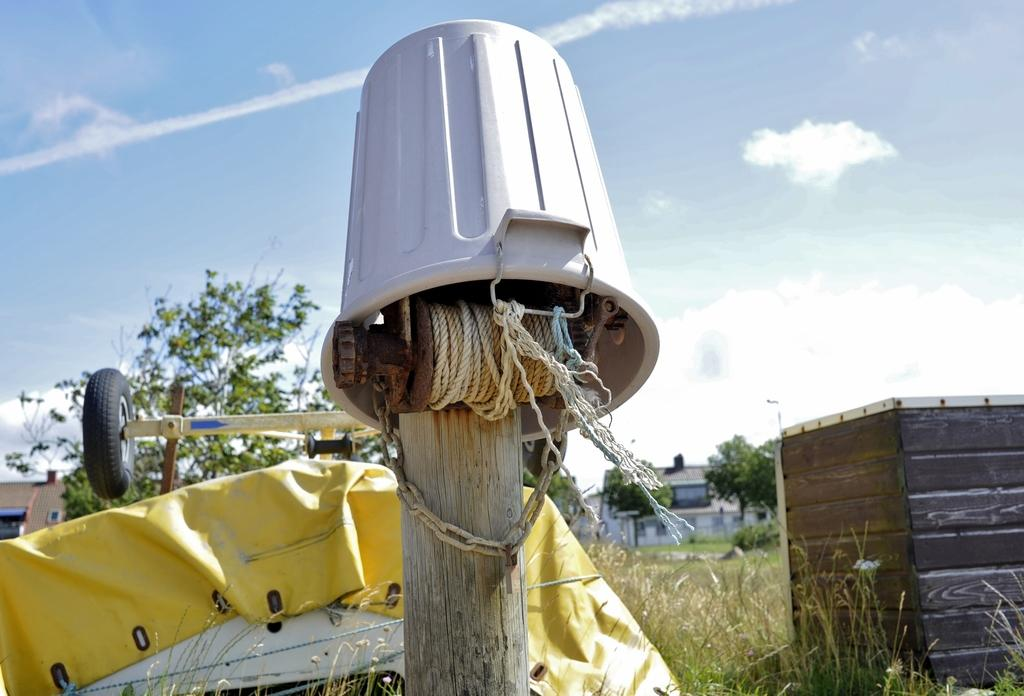What is the main object in the image? There is a wooden pole in the image. What is attached to the wooden pole? A machine is attached to the wooden pole. What is hanging from the wooden pole? There is a bucket on the wooden pole. How many objects can be seen in the image? There are two objects in the image, the wooden pole and the machine. What type of vegetation is visible in the image? There is grass visible in the image. What can be seen in the background of the image? There are houses, trees, and the sky visible in the background of the image. What type of cord is used to tie the pig to the wooden pole in the image? There is no pig present in the image, so there is no cord used to tie it to the wooden pole. How does the person in the image get a haircut while standing near the wooden pole? There is no person getting a haircut in the image, so this scenario cannot be observed. 